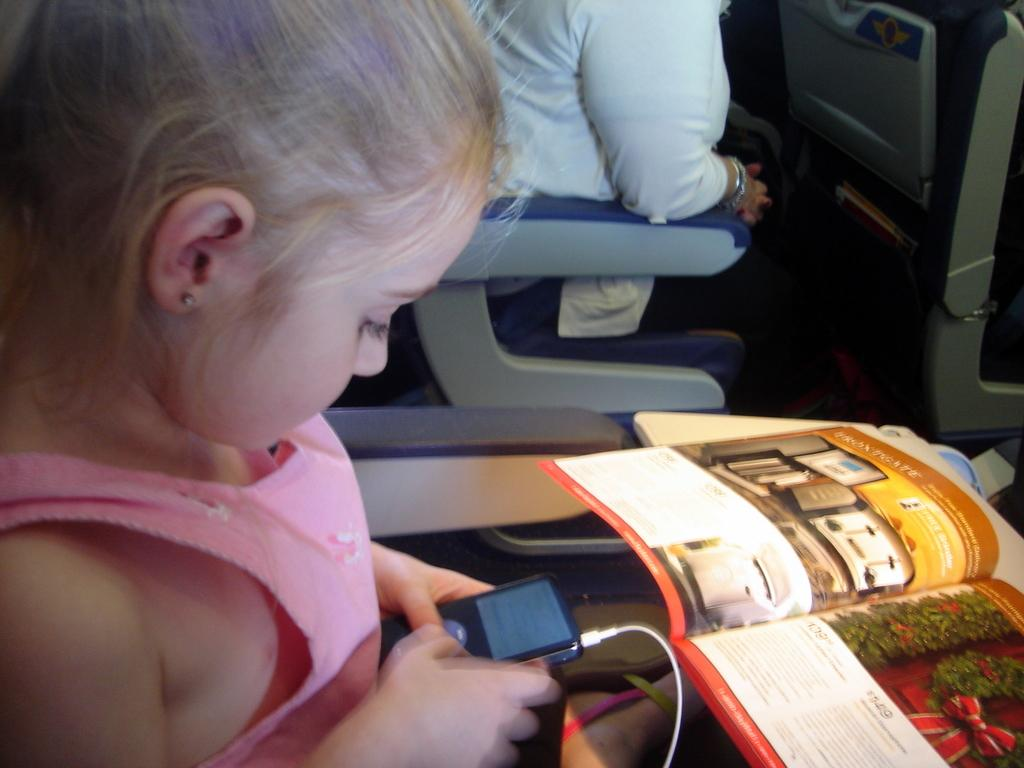Who is present in the image? There is a girl in the image. What is the girl doing in the image? The girl is sitting in a vehicle. What is the girl holding in the image? The girl is holding an electronic device. What else can be seen in the image? There is a book in the image. Are there any other people in the vehicle? Yes, there is a person sitting behind the girl in the vehicle. Can you see any sea creatures in the image? There are no sea creatures present in the image; it features a girl sitting in a vehicle. What type of thread is being used to sew the book in the image? There is no thread or sewing activity present in the image; it features a girl holding an electronic device and a book. 